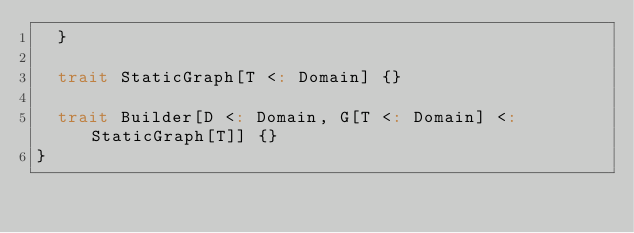Convert code to text. <code><loc_0><loc_0><loc_500><loc_500><_Scala_>  }

  trait StaticGraph[T <: Domain] {}

  trait Builder[D <: Domain, G[T <: Domain] <: StaticGraph[T]] {}
}
</code> 